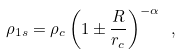<formula> <loc_0><loc_0><loc_500><loc_500>\rho _ { 1 s } = \rho _ { c } \left ( 1 \pm \frac { R } { r _ { c } } \right ) ^ { - \alpha } \ ,</formula> 